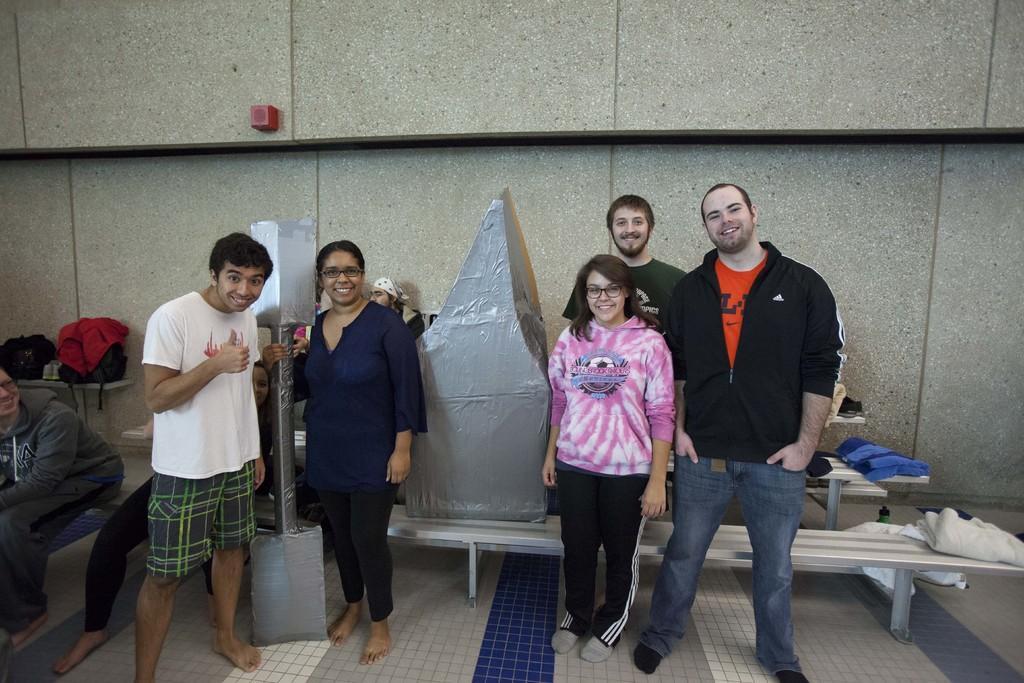How would you summarize this image in a sentence or two? In this picture we can see a few people standing and smiling. There is a woman holding a grey object. We can see some towels and another grey object on the benches. There is a white color object on the floor. We can see two women sitting on the bench. There are bags and footwear on the shelf. We can see a red object on the wall. 